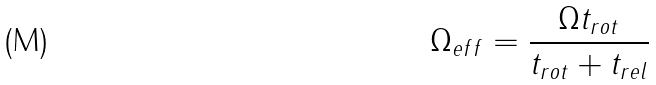<formula> <loc_0><loc_0><loc_500><loc_500>\Omega _ { e f f } = \frac { \Omega t _ { r o t } } { t _ { r o t } + t _ { r e l } }</formula> 